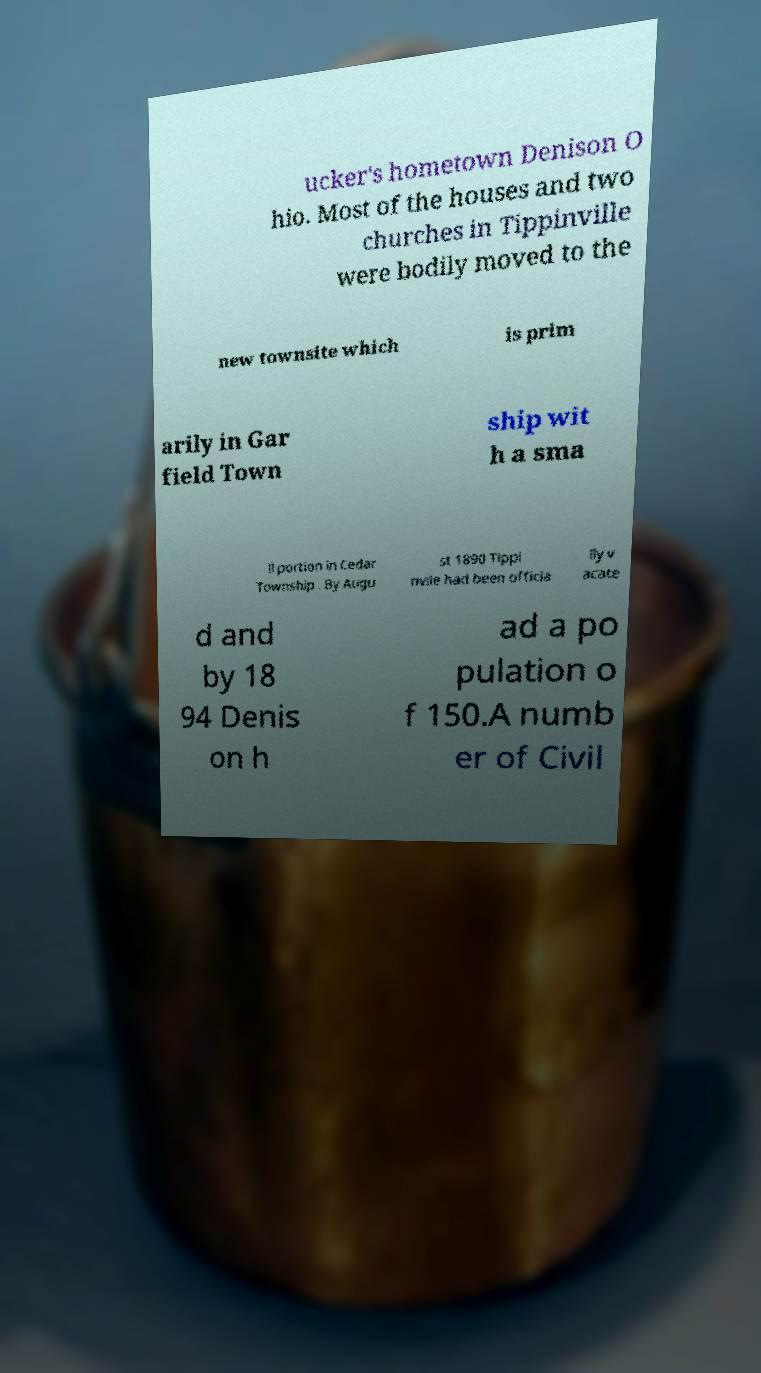I need the written content from this picture converted into text. Can you do that? ucker's hometown Denison O hio. Most of the houses and two churches in Tippinville were bodily moved to the new townsite which is prim arily in Gar field Town ship wit h a sma ll portion in Cedar Township . By Augu st 1890 Tippi nvile had been officia lly v acate d and by 18 94 Denis on h ad a po pulation o f 150.A numb er of Civil 